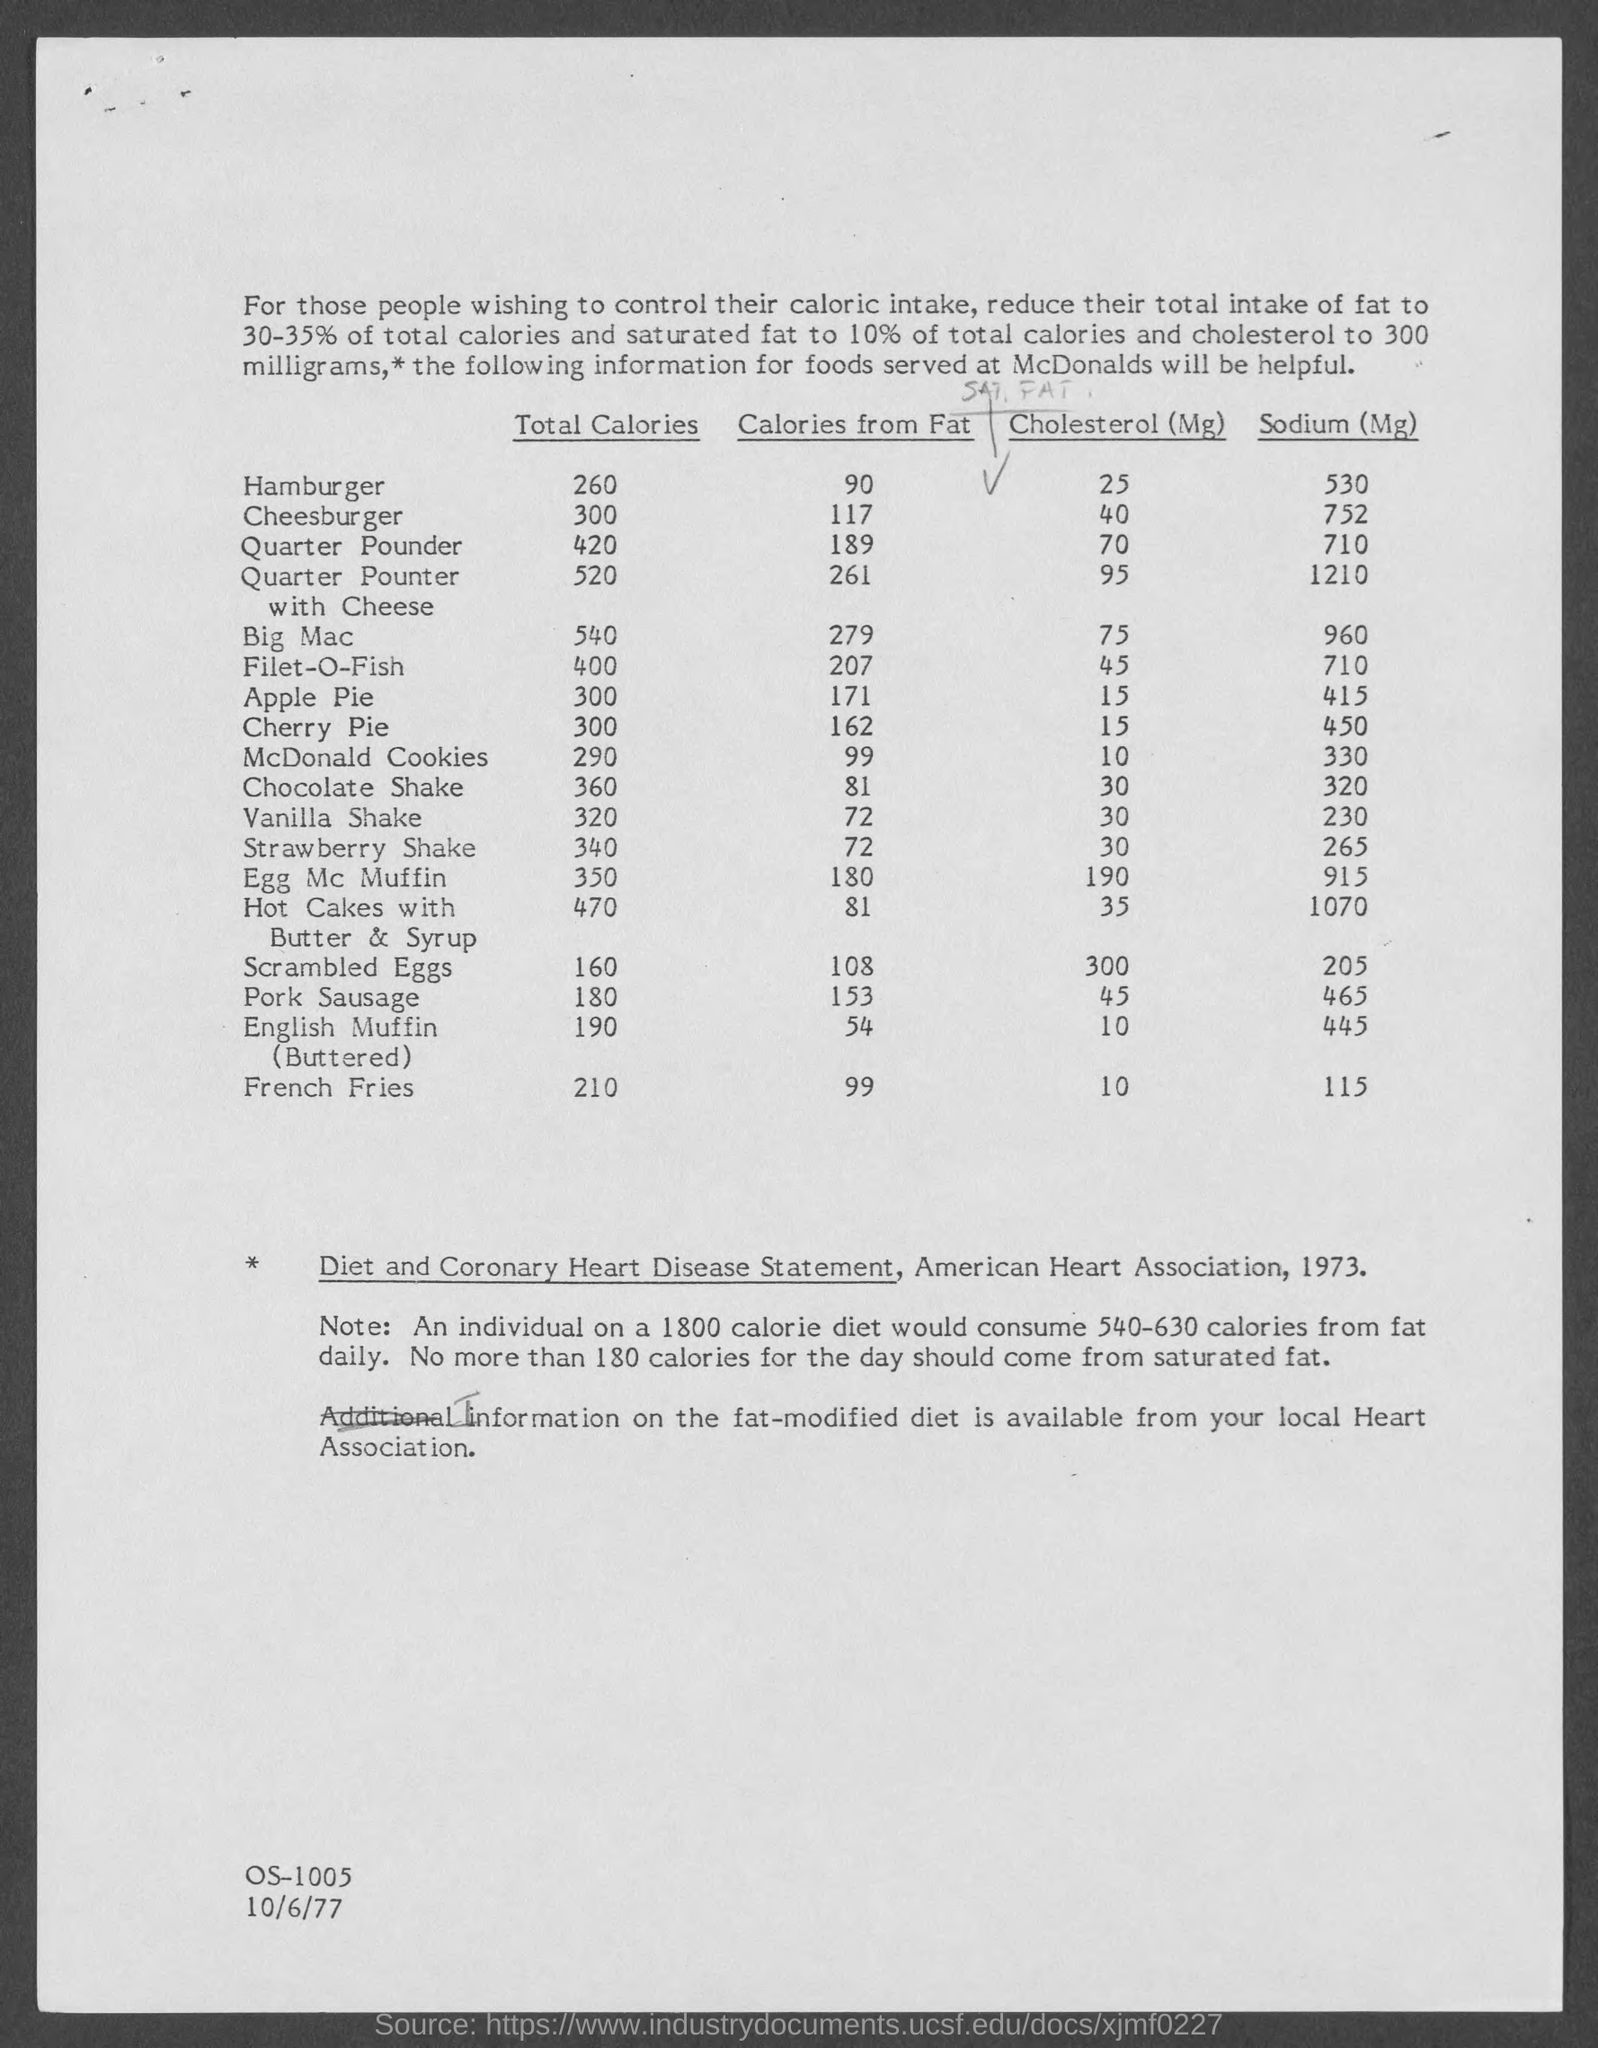Mention a couple of crucial points in this snapshot. The total calorie content of an apple pie is 300. The amount of cholesterol in pork sausage is 45 milligrams per serving. There are 90 calories from fat in a hamburger. The amount of sodium in French fries is 115. The date mentioned in the document is 10/6/77. 